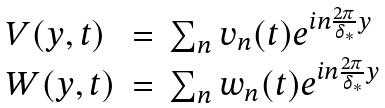<formula> <loc_0><loc_0><loc_500><loc_500>\begin{array} { l l l } V ( y , t ) & = & \sum _ { n } v _ { n } ( t ) e ^ { i n \frac { 2 \pi } { \delta _ { * } } y } \\ W ( y , t ) & = & \sum _ { n } w _ { n } ( t ) e ^ { i n \frac { 2 \pi } { \delta _ { * } } y } \end{array}</formula> 